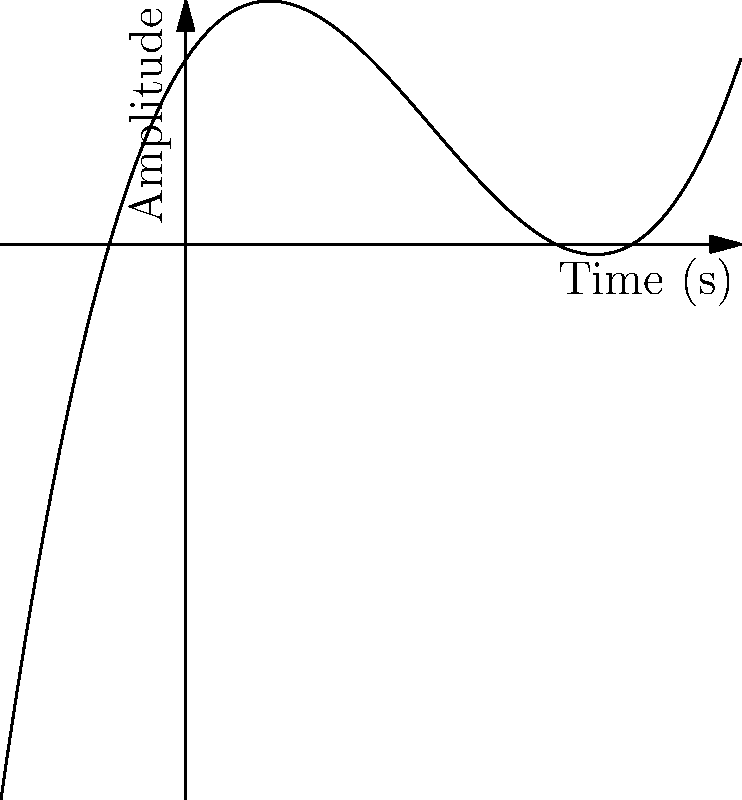You're working on a new track in your home studio. The sound engineer explains that a certain synthesizer effect can be modeled by the polynomial function $f(x) = 0.5x^3 - 2x^2 + 1.5x + 1$, where $x$ represents time in seconds and $f(x)$ represents the amplitude of the sound wave. At what point in time does the amplitude of this sound wave reach its minimum value within the interval $[0, 2]$ seconds? To find the minimum value of the function within the given interval, we need to follow these steps:

1. Find the derivative of the function:
   $f'(x) = 1.5x^2 - 4x + 1.5$

2. Set the derivative equal to zero and solve for x:
   $1.5x^2 - 4x + 1.5 = 0$
   $1.5(x^2 - \frac{8}{3}x + 1) = 0$
   $x^2 - \frac{8}{3}x + 1 = 0$

3. Use the quadratic formula to solve this equation:
   $x = \frac{8/3 \pm \sqrt{(8/3)^2 - 4(1)(1)}}{2(1)}$
   $x = \frac{8/3 \pm \sqrt{64/9 - 4}}{2}$
   $x = \frac{8/3 \pm \sqrt{28/9}}{2}$
   $x = \frac{4 \pm \sqrt{28}/3}{2}$

4. This gives us two critical points:
   $x_1 = \frac{4 + \sqrt{28}/3}{2} \approx 2.55$ (outside our interval)
   $x_2 = \frac{4 - \sqrt{28}/3}{2} \approx 1.45$

5. Since we're looking within the interval $[0, 2]$, we need to check the function value at $x = 0$, $x = 1.45$, and $x = 2$:
   $f(0) = 1$
   $f(1.45) \approx 0.52$
   $f(2) = 1$

6. The minimum value occurs at $x \approx 1.45$ seconds.
Answer: 1.45 seconds 